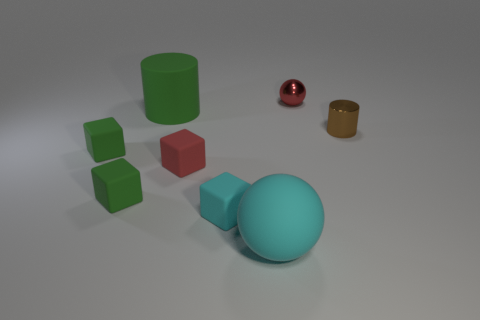Subtract all tiny red matte cubes. How many cubes are left? 3 Add 2 small cyan rubber blocks. How many objects exist? 10 Subtract all cylinders. How many objects are left? 6 Subtract all green cubes. How many cubes are left? 2 Subtract all green cylinders. Subtract all blue blocks. How many cylinders are left? 1 Subtract all brown blocks. How many cyan cylinders are left? 0 Subtract all tiny brown cylinders. Subtract all metallic cylinders. How many objects are left? 6 Add 6 cyan matte balls. How many cyan matte balls are left? 7 Add 2 green rubber objects. How many green rubber objects exist? 5 Subtract 1 green cylinders. How many objects are left? 7 